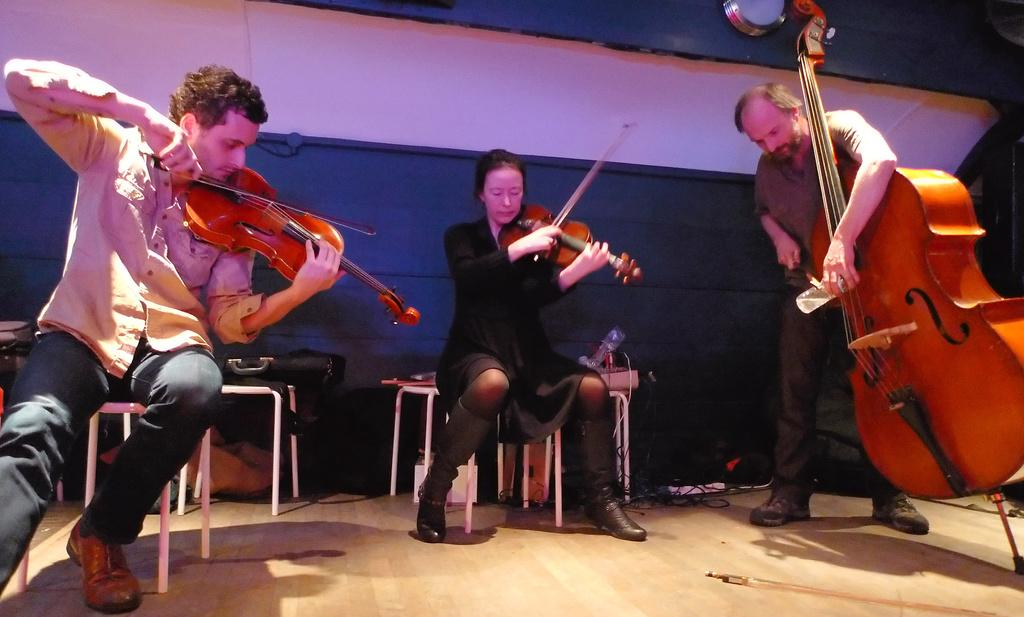How many people are in the image? There are three people in the image. What are the people in the image doing? Each of the three people is playing a violin. What type of magic is being performed by the people in the image? There is no indication of magic or any magical elements in the image; the people are simply playing violins. How many spiders are visible on the violins in the image? There are no spiders present in the image. 